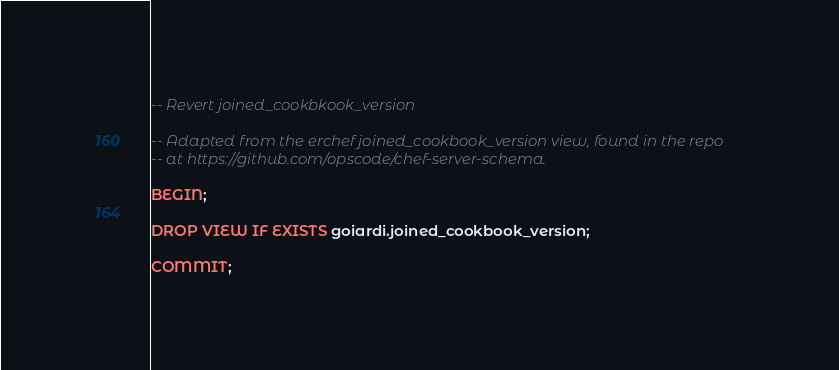<code> <loc_0><loc_0><loc_500><loc_500><_SQL_>-- Revert joined_cookbkook_version

-- Adapted from the erchef joined_cookbook_version view, found in the repo
-- at https://github.com/opscode/chef-server-schema.

BEGIN;

DROP VIEW IF EXISTS goiardi.joined_cookbook_version;

COMMIT;
</code> 